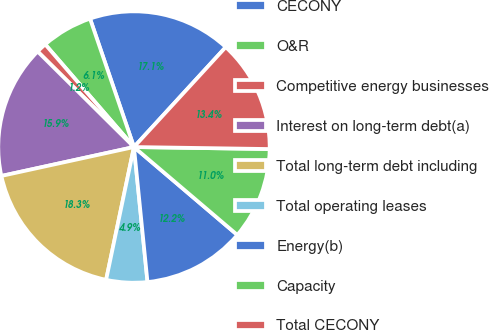Convert chart. <chart><loc_0><loc_0><loc_500><loc_500><pie_chart><fcel>CECONY<fcel>O&R<fcel>Competitive energy businesses<fcel>Interest on long-term debt(a)<fcel>Total long-term debt including<fcel>Total operating leases<fcel>Energy(b)<fcel>Capacity<fcel>Total CECONY<nl><fcel>17.07%<fcel>6.1%<fcel>1.22%<fcel>15.85%<fcel>18.29%<fcel>4.88%<fcel>12.19%<fcel>10.98%<fcel>13.41%<nl></chart> 